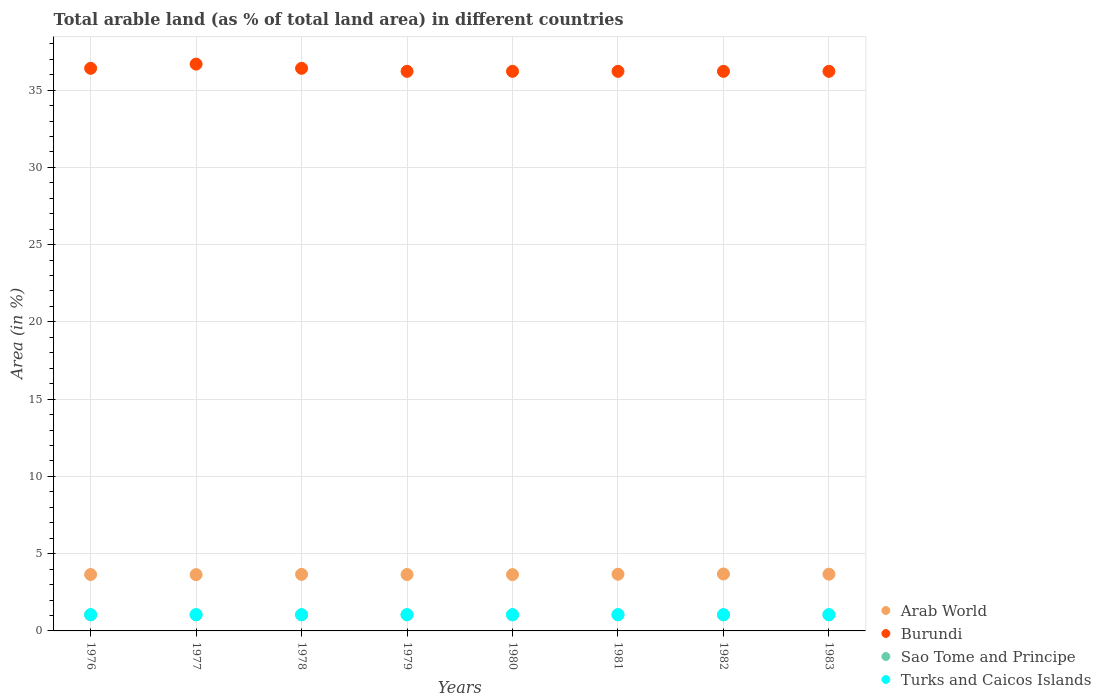What is the percentage of arable land in Burundi in 1980?
Ensure brevity in your answer.  36.21. Across all years, what is the maximum percentage of arable land in Burundi?
Your response must be concise. 36.68. Across all years, what is the minimum percentage of arable land in Arab World?
Offer a very short reply. 3.64. In which year was the percentage of arable land in Burundi maximum?
Your answer should be compact. 1977. In which year was the percentage of arable land in Arab World minimum?
Offer a very short reply. 1977. What is the total percentage of arable land in Turks and Caicos Islands in the graph?
Provide a succinct answer. 8.42. What is the difference between the percentage of arable land in Burundi in 1978 and that in 1979?
Keep it short and to the point. 0.19. What is the difference between the percentage of arable land in Arab World in 1979 and the percentage of arable land in Turks and Caicos Islands in 1983?
Offer a terse response. 2.6. What is the average percentage of arable land in Sao Tome and Principe per year?
Your response must be concise. 1.04. In the year 1980, what is the difference between the percentage of arable land in Turks and Caicos Islands and percentage of arable land in Arab World?
Provide a short and direct response. -2.59. What is the ratio of the percentage of arable land in Burundi in 1976 to that in 1983?
Offer a very short reply. 1.01. Is the difference between the percentage of arable land in Turks and Caicos Islands in 1981 and 1983 greater than the difference between the percentage of arable land in Arab World in 1981 and 1983?
Make the answer very short. Yes. In how many years, is the percentage of arable land in Arab World greater than the average percentage of arable land in Arab World taken over all years?
Provide a short and direct response. 4. Is the sum of the percentage of arable land in Burundi in 1980 and 1982 greater than the maximum percentage of arable land in Arab World across all years?
Offer a terse response. Yes. Is it the case that in every year, the sum of the percentage of arable land in Sao Tome and Principe and percentage of arable land in Burundi  is greater than the sum of percentage of arable land in Turks and Caicos Islands and percentage of arable land in Arab World?
Offer a terse response. Yes. Is it the case that in every year, the sum of the percentage of arable land in Turks and Caicos Islands and percentage of arable land in Burundi  is greater than the percentage of arable land in Arab World?
Ensure brevity in your answer.  Yes. Does the percentage of arable land in Turks and Caicos Islands monotonically increase over the years?
Your answer should be compact. No. Is the percentage of arable land in Burundi strictly less than the percentage of arable land in Arab World over the years?
Your answer should be compact. No. How many years are there in the graph?
Offer a very short reply. 8. What is the difference between two consecutive major ticks on the Y-axis?
Your response must be concise. 5. Does the graph contain any zero values?
Keep it short and to the point. No. Does the graph contain grids?
Offer a terse response. Yes. Where does the legend appear in the graph?
Provide a succinct answer. Bottom right. How are the legend labels stacked?
Make the answer very short. Vertical. What is the title of the graph?
Offer a terse response. Total arable land (as % of total land area) in different countries. What is the label or title of the X-axis?
Keep it short and to the point. Years. What is the label or title of the Y-axis?
Your response must be concise. Area (in %). What is the Area (in %) in Arab World in 1976?
Provide a short and direct response. 3.65. What is the Area (in %) of Burundi in 1976?
Provide a succinct answer. 36.41. What is the Area (in %) in Sao Tome and Principe in 1976?
Your response must be concise. 1.04. What is the Area (in %) in Turks and Caicos Islands in 1976?
Make the answer very short. 1.05. What is the Area (in %) of Arab World in 1977?
Provide a succinct answer. 3.64. What is the Area (in %) in Burundi in 1977?
Make the answer very short. 36.68. What is the Area (in %) of Sao Tome and Principe in 1977?
Provide a succinct answer. 1.04. What is the Area (in %) of Turks and Caicos Islands in 1977?
Make the answer very short. 1.05. What is the Area (in %) in Arab World in 1978?
Ensure brevity in your answer.  3.66. What is the Area (in %) of Burundi in 1978?
Offer a very short reply. 36.41. What is the Area (in %) of Sao Tome and Principe in 1978?
Offer a terse response. 1.04. What is the Area (in %) in Turks and Caicos Islands in 1978?
Your response must be concise. 1.05. What is the Area (in %) in Arab World in 1979?
Offer a terse response. 3.65. What is the Area (in %) in Burundi in 1979?
Provide a succinct answer. 36.21. What is the Area (in %) of Sao Tome and Principe in 1979?
Your answer should be very brief. 1.04. What is the Area (in %) of Turks and Caicos Islands in 1979?
Keep it short and to the point. 1.05. What is the Area (in %) of Arab World in 1980?
Your answer should be very brief. 3.64. What is the Area (in %) in Burundi in 1980?
Your response must be concise. 36.21. What is the Area (in %) of Sao Tome and Principe in 1980?
Provide a succinct answer. 1.04. What is the Area (in %) of Turks and Caicos Islands in 1980?
Your answer should be compact. 1.05. What is the Area (in %) in Arab World in 1981?
Your answer should be compact. 3.67. What is the Area (in %) in Burundi in 1981?
Your answer should be compact. 36.21. What is the Area (in %) in Sao Tome and Principe in 1981?
Ensure brevity in your answer.  1.04. What is the Area (in %) in Turks and Caicos Islands in 1981?
Offer a terse response. 1.05. What is the Area (in %) of Arab World in 1982?
Keep it short and to the point. 3.68. What is the Area (in %) of Burundi in 1982?
Offer a very short reply. 36.21. What is the Area (in %) of Sao Tome and Principe in 1982?
Offer a terse response. 1.04. What is the Area (in %) of Turks and Caicos Islands in 1982?
Provide a succinct answer. 1.05. What is the Area (in %) of Arab World in 1983?
Provide a short and direct response. 3.67. What is the Area (in %) in Burundi in 1983?
Provide a succinct answer. 36.21. What is the Area (in %) in Sao Tome and Principe in 1983?
Ensure brevity in your answer.  1.04. What is the Area (in %) of Turks and Caicos Islands in 1983?
Offer a terse response. 1.05. Across all years, what is the maximum Area (in %) in Arab World?
Offer a terse response. 3.68. Across all years, what is the maximum Area (in %) of Burundi?
Keep it short and to the point. 36.68. Across all years, what is the maximum Area (in %) of Sao Tome and Principe?
Provide a succinct answer. 1.04. Across all years, what is the maximum Area (in %) of Turks and Caicos Islands?
Offer a very short reply. 1.05. Across all years, what is the minimum Area (in %) of Arab World?
Provide a succinct answer. 3.64. Across all years, what is the minimum Area (in %) in Burundi?
Provide a succinct answer. 36.21. Across all years, what is the minimum Area (in %) of Sao Tome and Principe?
Provide a succinct answer. 1.04. Across all years, what is the minimum Area (in %) in Turks and Caicos Islands?
Your answer should be compact. 1.05. What is the total Area (in %) in Arab World in the graph?
Make the answer very short. 29.27. What is the total Area (in %) in Burundi in the graph?
Provide a succinct answer. 290.58. What is the total Area (in %) of Sao Tome and Principe in the graph?
Your answer should be very brief. 8.33. What is the total Area (in %) of Turks and Caicos Islands in the graph?
Offer a terse response. 8.42. What is the difference between the Area (in %) of Arab World in 1976 and that in 1977?
Offer a terse response. 0.01. What is the difference between the Area (in %) in Burundi in 1976 and that in 1977?
Keep it short and to the point. -0.27. What is the difference between the Area (in %) in Arab World in 1976 and that in 1978?
Ensure brevity in your answer.  -0.01. What is the difference between the Area (in %) of Burundi in 1976 and that in 1978?
Provide a short and direct response. 0. What is the difference between the Area (in %) of Sao Tome and Principe in 1976 and that in 1978?
Offer a very short reply. 0. What is the difference between the Area (in %) of Turks and Caicos Islands in 1976 and that in 1978?
Your answer should be very brief. 0. What is the difference between the Area (in %) in Arab World in 1976 and that in 1979?
Your answer should be very brief. -0. What is the difference between the Area (in %) of Burundi in 1976 and that in 1979?
Ensure brevity in your answer.  0.19. What is the difference between the Area (in %) in Sao Tome and Principe in 1976 and that in 1979?
Your answer should be compact. 0. What is the difference between the Area (in %) in Arab World in 1976 and that in 1980?
Offer a terse response. 0.01. What is the difference between the Area (in %) of Burundi in 1976 and that in 1980?
Keep it short and to the point. 0.19. What is the difference between the Area (in %) of Turks and Caicos Islands in 1976 and that in 1980?
Offer a very short reply. 0. What is the difference between the Area (in %) in Arab World in 1976 and that in 1981?
Ensure brevity in your answer.  -0.02. What is the difference between the Area (in %) of Burundi in 1976 and that in 1981?
Provide a short and direct response. 0.19. What is the difference between the Area (in %) of Sao Tome and Principe in 1976 and that in 1981?
Provide a short and direct response. 0. What is the difference between the Area (in %) in Turks and Caicos Islands in 1976 and that in 1981?
Offer a terse response. 0. What is the difference between the Area (in %) of Arab World in 1976 and that in 1982?
Offer a very short reply. -0.03. What is the difference between the Area (in %) of Burundi in 1976 and that in 1982?
Keep it short and to the point. 0.19. What is the difference between the Area (in %) in Turks and Caicos Islands in 1976 and that in 1982?
Ensure brevity in your answer.  0. What is the difference between the Area (in %) in Arab World in 1976 and that in 1983?
Provide a short and direct response. -0.02. What is the difference between the Area (in %) in Burundi in 1976 and that in 1983?
Offer a terse response. 0.19. What is the difference between the Area (in %) of Turks and Caicos Islands in 1976 and that in 1983?
Keep it short and to the point. 0. What is the difference between the Area (in %) in Arab World in 1977 and that in 1978?
Make the answer very short. -0.02. What is the difference between the Area (in %) of Burundi in 1977 and that in 1978?
Keep it short and to the point. 0.27. What is the difference between the Area (in %) of Arab World in 1977 and that in 1979?
Your answer should be very brief. -0.01. What is the difference between the Area (in %) in Burundi in 1977 and that in 1979?
Your answer should be compact. 0.47. What is the difference between the Area (in %) of Sao Tome and Principe in 1977 and that in 1979?
Provide a short and direct response. 0. What is the difference between the Area (in %) of Turks and Caicos Islands in 1977 and that in 1979?
Your response must be concise. 0. What is the difference between the Area (in %) in Arab World in 1977 and that in 1980?
Keep it short and to the point. -0. What is the difference between the Area (in %) in Burundi in 1977 and that in 1980?
Offer a terse response. 0.47. What is the difference between the Area (in %) in Sao Tome and Principe in 1977 and that in 1980?
Ensure brevity in your answer.  0. What is the difference between the Area (in %) in Arab World in 1977 and that in 1981?
Provide a succinct answer. -0.03. What is the difference between the Area (in %) of Burundi in 1977 and that in 1981?
Your answer should be very brief. 0.47. What is the difference between the Area (in %) of Turks and Caicos Islands in 1977 and that in 1981?
Ensure brevity in your answer.  0. What is the difference between the Area (in %) of Arab World in 1977 and that in 1982?
Provide a succinct answer. -0.04. What is the difference between the Area (in %) of Burundi in 1977 and that in 1982?
Provide a succinct answer. 0.47. What is the difference between the Area (in %) of Sao Tome and Principe in 1977 and that in 1982?
Your answer should be very brief. 0. What is the difference between the Area (in %) of Turks and Caicos Islands in 1977 and that in 1982?
Offer a terse response. 0. What is the difference between the Area (in %) of Arab World in 1977 and that in 1983?
Offer a terse response. -0.03. What is the difference between the Area (in %) in Burundi in 1977 and that in 1983?
Your answer should be compact. 0.47. What is the difference between the Area (in %) of Sao Tome and Principe in 1977 and that in 1983?
Your answer should be very brief. 0. What is the difference between the Area (in %) in Arab World in 1978 and that in 1979?
Offer a very short reply. 0.01. What is the difference between the Area (in %) in Burundi in 1978 and that in 1979?
Ensure brevity in your answer.  0.19. What is the difference between the Area (in %) of Arab World in 1978 and that in 1980?
Provide a succinct answer. 0.01. What is the difference between the Area (in %) of Burundi in 1978 and that in 1980?
Your response must be concise. 0.19. What is the difference between the Area (in %) in Arab World in 1978 and that in 1981?
Offer a terse response. -0.01. What is the difference between the Area (in %) of Burundi in 1978 and that in 1981?
Keep it short and to the point. 0.19. What is the difference between the Area (in %) in Turks and Caicos Islands in 1978 and that in 1981?
Provide a short and direct response. 0. What is the difference between the Area (in %) in Arab World in 1978 and that in 1982?
Ensure brevity in your answer.  -0.03. What is the difference between the Area (in %) in Burundi in 1978 and that in 1982?
Keep it short and to the point. 0.19. What is the difference between the Area (in %) of Turks and Caicos Islands in 1978 and that in 1982?
Provide a succinct answer. 0. What is the difference between the Area (in %) in Arab World in 1978 and that in 1983?
Provide a succinct answer. -0.01. What is the difference between the Area (in %) in Burundi in 1978 and that in 1983?
Offer a terse response. 0.19. What is the difference between the Area (in %) of Turks and Caicos Islands in 1978 and that in 1983?
Ensure brevity in your answer.  0. What is the difference between the Area (in %) of Arab World in 1979 and that in 1980?
Give a very brief answer. 0.01. What is the difference between the Area (in %) of Burundi in 1979 and that in 1980?
Your response must be concise. 0. What is the difference between the Area (in %) of Arab World in 1979 and that in 1981?
Offer a very short reply. -0.02. What is the difference between the Area (in %) in Turks and Caicos Islands in 1979 and that in 1981?
Make the answer very short. 0. What is the difference between the Area (in %) of Arab World in 1979 and that in 1982?
Offer a very short reply. -0.03. What is the difference between the Area (in %) in Burundi in 1979 and that in 1982?
Keep it short and to the point. 0. What is the difference between the Area (in %) in Sao Tome and Principe in 1979 and that in 1982?
Give a very brief answer. 0. What is the difference between the Area (in %) of Turks and Caicos Islands in 1979 and that in 1982?
Your response must be concise. 0. What is the difference between the Area (in %) in Arab World in 1979 and that in 1983?
Your response must be concise. -0.02. What is the difference between the Area (in %) in Sao Tome and Principe in 1979 and that in 1983?
Provide a succinct answer. 0. What is the difference between the Area (in %) of Arab World in 1980 and that in 1981?
Keep it short and to the point. -0.02. What is the difference between the Area (in %) of Burundi in 1980 and that in 1981?
Offer a terse response. 0. What is the difference between the Area (in %) of Turks and Caicos Islands in 1980 and that in 1981?
Make the answer very short. 0. What is the difference between the Area (in %) of Arab World in 1980 and that in 1982?
Provide a succinct answer. -0.04. What is the difference between the Area (in %) in Burundi in 1980 and that in 1982?
Ensure brevity in your answer.  0. What is the difference between the Area (in %) in Arab World in 1980 and that in 1983?
Provide a succinct answer. -0.03. What is the difference between the Area (in %) of Burundi in 1980 and that in 1983?
Provide a short and direct response. 0. What is the difference between the Area (in %) in Arab World in 1981 and that in 1982?
Offer a very short reply. -0.02. What is the difference between the Area (in %) in Burundi in 1981 and that in 1982?
Give a very brief answer. 0. What is the difference between the Area (in %) in Sao Tome and Principe in 1981 and that in 1982?
Give a very brief answer. 0. What is the difference between the Area (in %) of Turks and Caicos Islands in 1981 and that in 1982?
Your response must be concise. 0. What is the difference between the Area (in %) of Arab World in 1981 and that in 1983?
Your answer should be compact. -0. What is the difference between the Area (in %) in Arab World in 1982 and that in 1983?
Offer a very short reply. 0.01. What is the difference between the Area (in %) in Burundi in 1982 and that in 1983?
Provide a short and direct response. 0. What is the difference between the Area (in %) in Arab World in 1976 and the Area (in %) in Burundi in 1977?
Your response must be concise. -33.03. What is the difference between the Area (in %) of Arab World in 1976 and the Area (in %) of Sao Tome and Principe in 1977?
Make the answer very short. 2.61. What is the difference between the Area (in %) of Arab World in 1976 and the Area (in %) of Turks and Caicos Islands in 1977?
Provide a short and direct response. 2.6. What is the difference between the Area (in %) of Burundi in 1976 and the Area (in %) of Sao Tome and Principe in 1977?
Provide a short and direct response. 35.37. What is the difference between the Area (in %) of Burundi in 1976 and the Area (in %) of Turks and Caicos Islands in 1977?
Ensure brevity in your answer.  35.36. What is the difference between the Area (in %) in Sao Tome and Principe in 1976 and the Area (in %) in Turks and Caicos Islands in 1977?
Make the answer very short. -0.01. What is the difference between the Area (in %) in Arab World in 1976 and the Area (in %) in Burundi in 1978?
Your answer should be very brief. -32.76. What is the difference between the Area (in %) of Arab World in 1976 and the Area (in %) of Sao Tome and Principe in 1978?
Your response must be concise. 2.61. What is the difference between the Area (in %) in Arab World in 1976 and the Area (in %) in Turks and Caicos Islands in 1978?
Offer a terse response. 2.6. What is the difference between the Area (in %) of Burundi in 1976 and the Area (in %) of Sao Tome and Principe in 1978?
Offer a very short reply. 35.37. What is the difference between the Area (in %) of Burundi in 1976 and the Area (in %) of Turks and Caicos Islands in 1978?
Keep it short and to the point. 35.36. What is the difference between the Area (in %) of Sao Tome and Principe in 1976 and the Area (in %) of Turks and Caicos Islands in 1978?
Make the answer very short. -0.01. What is the difference between the Area (in %) in Arab World in 1976 and the Area (in %) in Burundi in 1979?
Ensure brevity in your answer.  -32.56. What is the difference between the Area (in %) of Arab World in 1976 and the Area (in %) of Sao Tome and Principe in 1979?
Offer a terse response. 2.61. What is the difference between the Area (in %) in Arab World in 1976 and the Area (in %) in Turks and Caicos Islands in 1979?
Make the answer very short. 2.6. What is the difference between the Area (in %) of Burundi in 1976 and the Area (in %) of Sao Tome and Principe in 1979?
Offer a terse response. 35.37. What is the difference between the Area (in %) of Burundi in 1976 and the Area (in %) of Turks and Caicos Islands in 1979?
Your answer should be compact. 35.36. What is the difference between the Area (in %) of Sao Tome and Principe in 1976 and the Area (in %) of Turks and Caicos Islands in 1979?
Keep it short and to the point. -0.01. What is the difference between the Area (in %) of Arab World in 1976 and the Area (in %) of Burundi in 1980?
Keep it short and to the point. -32.56. What is the difference between the Area (in %) of Arab World in 1976 and the Area (in %) of Sao Tome and Principe in 1980?
Provide a succinct answer. 2.61. What is the difference between the Area (in %) of Arab World in 1976 and the Area (in %) of Turks and Caicos Islands in 1980?
Your answer should be compact. 2.6. What is the difference between the Area (in %) of Burundi in 1976 and the Area (in %) of Sao Tome and Principe in 1980?
Give a very brief answer. 35.37. What is the difference between the Area (in %) in Burundi in 1976 and the Area (in %) in Turks and Caicos Islands in 1980?
Offer a terse response. 35.36. What is the difference between the Area (in %) of Sao Tome and Principe in 1976 and the Area (in %) of Turks and Caicos Islands in 1980?
Your answer should be very brief. -0.01. What is the difference between the Area (in %) of Arab World in 1976 and the Area (in %) of Burundi in 1981?
Give a very brief answer. -32.56. What is the difference between the Area (in %) of Arab World in 1976 and the Area (in %) of Sao Tome and Principe in 1981?
Offer a terse response. 2.61. What is the difference between the Area (in %) of Arab World in 1976 and the Area (in %) of Turks and Caicos Islands in 1981?
Provide a succinct answer. 2.6. What is the difference between the Area (in %) in Burundi in 1976 and the Area (in %) in Sao Tome and Principe in 1981?
Your response must be concise. 35.37. What is the difference between the Area (in %) in Burundi in 1976 and the Area (in %) in Turks and Caicos Islands in 1981?
Your answer should be compact. 35.36. What is the difference between the Area (in %) of Sao Tome and Principe in 1976 and the Area (in %) of Turks and Caicos Islands in 1981?
Your answer should be compact. -0.01. What is the difference between the Area (in %) of Arab World in 1976 and the Area (in %) of Burundi in 1982?
Keep it short and to the point. -32.56. What is the difference between the Area (in %) of Arab World in 1976 and the Area (in %) of Sao Tome and Principe in 1982?
Offer a terse response. 2.61. What is the difference between the Area (in %) of Arab World in 1976 and the Area (in %) of Turks and Caicos Islands in 1982?
Your answer should be compact. 2.6. What is the difference between the Area (in %) of Burundi in 1976 and the Area (in %) of Sao Tome and Principe in 1982?
Your answer should be very brief. 35.37. What is the difference between the Area (in %) of Burundi in 1976 and the Area (in %) of Turks and Caicos Islands in 1982?
Provide a short and direct response. 35.36. What is the difference between the Area (in %) in Sao Tome and Principe in 1976 and the Area (in %) in Turks and Caicos Islands in 1982?
Ensure brevity in your answer.  -0.01. What is the difference between the Area (in %) in Arab World in 1976 and the Area (in %) in Burundi in 1983?
Ensure brevity in your answer.  -32.56. What is the difference between the Area (in %) of Arab World in 1976 and the Area (in %) of Sao Tome and Principe in 1983?
Your response must be concise. 2.61. What is the difference between the Area (in %) of Arab World in 1976 and the Area (in %) of Turks and Caicos Islands in 1983?
Ensure brevity in your answer.  2.6. What is the difference between the Area (in %) in Burundi in 1976 and the Area (in %) in Sao Tome and Principe in 1983?
Give a very brief answer. 35.37. What is the difference between the Area (in %) of Burundi in 1976 and the Area (in %) of Turks and Caicos Islands in 1983?
Offer a terse response. 35.36. What is the difference between the Area (in %) of Sao Tome and Principe in 1976 and the Area (in %) of Turks and Caicos Islands in 1983?
Your answer should be very brief. -0.01. What is the difference between the Area (in %) in Arab World in 1977 and the Area (in %) in Burundi in 1978?
Keep it short and to the point. -32.77. What is the difference between the Area (in %) in Arab World in 1977 and the Area (in %) in Sao Tome and Principe in 1978?
Provide a succinct answer. 2.6. What is the difference between the Area (in %) in Arab World in 1977 and the Area (in %) in Turks and Caicos Islands in 1978?
Your answer should be very brief. 2.59. What is the difference between the Area (in %) in Burundi in 1977 and the Area (in %) in Sao Tome and Principe in 1978?
Provide a succinct answer. 35.64. What is the difference between the Area (in %) in Burundi in 1977 and the Area (in %) in Turks and Caicos Islands in 1978?
Offer a terse response. 35.63. What is the difference between the Area (in %) in Sao Tome and Principe in 1977 and the Area (in %) in Turks and Caicos Islands in 1978?
Provide a short and direct response. -0.01. What is the difference between the Area (in %) of Arab World in 1977 and the Area (in %) of Burundi in 1979?
Provide a succinct answer. -32.57. What is the difference between the Area (in %) of Arab World in 1977 and the Area (in %) of Sao Tome and Principe in 1979?
Provide a short and direct response. 2.6. What is the difference between the Area (in %) of Arab World in 1977 and the Area (in %) of Turks and Caicos Islands in 1979?
Provide a succinct answer. 2.59. What is the difference between the Area (in %) in Burundi in 1977 and the Area (in %) in Sao Tome and Principe in 1979?
Your answer should be compact. 35.64. What is the difference between the Area (in %) in Burundi in 1977 and the Area (in %) in Turks and Caicos Islands in 1979?
Provide a succinct answer. 35.63. What is the difference between the Area (in %) of Sao Tome and Principe in 1977 and the Area (in %) of Turks and Caicos Islands in 1979?
Your response must be concise. -0.01. What is the difference between the Area (in %) of Arab World in 1977 and the Area (in %) of Burundi in 1980?
Offer a terse response. -32.57. What is the difference between the Area (in %) of Arab World in 1977 and the Area (in %) of Sao Tome and Principe in 1980?
Provide a succinct answer. 2.6. What is the difference between the Area (in %) of Arab World in 1977 and the Area (in %) of Turks and Caicos Islands in 1980?
Provide a succinct answer. 2.59. What is the difference between the Area (in %) of Burundi in 1977 and the Area (in %) of Sao Tome and Principe in 1980?
Your answer should be compact. 35.64. What is the difference between the Area (in %) of Burundi in 1977 and the Area (in %) of Turks and Caicos Islands in 1980?
Make the answer very short. 35.63. What is the difference between the Area (in %) in Sao Tome and Principe in 1977 and the Area (in %) in Turks and Caicos Islands in 1980?
Provide a succinct answer. -0.01. What is the difference between the Area (in %) in Arab World in 1977 and the Area (in %) in Burundi in 1981?
Ensure brevity in your answer.  -32.57. What is the difference between the Area (in %) of Arab World in 1977 and the Area (in %) of Sao Tome and Principe in 1981?
Give a very brief answer. 2.6. What is the difference between the Area (in %) in Arab World in 1977 and the Area (in %) in Turks and Caicos Islands in 1981?
Your answer should be very brief. 2.59. What is the difference between the Area (in %) in Burundi in 1977 and the Area (in %) in Sao Tome and Principe in 1981?
Provide a short and direct response. 35.64. What is the difference between the Area (in %) in Burundi in 1977 and the Area (in %) in Turks and Caicos Islands in 1981?
Provide a short and direct response. 35.63. What is the difference between the Area (in %) of Sao Tome and Principe in 1977 and the Area (in %) of Turks and Caicos Islands in 1981?
Your answer should be very brief. -0.01. What is the difference between the Area (in %) of Arab World in 1977 and the Area (in %) of Burundi in 1982?
Make the answer very short. -32.57. What is the difference between the Area (in %) of Arab World in 1977 and the Area (in %) of Sao Tome and Principe in 1982?
Your answer should be compact. 2.6. What is the difference between the Area (in %) in Arab World in 1977 and the Area (in %) in Turks and Caicos Islands in 1982?
Your answer should be compact. 2.59. What is the difference between the Area (in %) in Burundi in 1977 and the Area (in %) in Sao Tome and Principe in 1982?
Your answer should be compact. 35.64. What is the difference between the Area (in %) in Burundi in 1977 and the Area (in %) in Turks and Caicos Islands in 1982?
Ensure brevity in your answer.  35.63. What is the difference between the Area (in %) of Sao Tome and Principe in 1977 and the Area (in %) of Turks and Caicos Islands in 1982?
Your response must be concise. -0.01. What is the difference between the Area (in %) of Arab World in 1977 and the Area (in %) of Burundi in 1983?
Offer a very short reply. -32.57. What is the difference between the Area (in %) of Arab World in 1977 and the Area (in %) of Sao Tome and Principe in 1983?
Ensure brevity in your answer.  2.6. What is the difference between the Area (in %) in Arab World in 1977 and the Area (in %) in Turks and Caicos Islands in 1983?
Your response must be concise. 2.59. What is the difference between the Area (in %) of Burundi in 1977 and the Area (in %) of Sao Tome and Principe in 1983?
Your response must be concise. 35.64. What is the difference between the Area (in %) in Burundi in 1977 and the Area (in %) in Turks and Caicos Islands in 1983?
Ensure brevity in your answer.  35.63. What is the difference between the Area (in %) of Sao Tome and Principe in 1977 and the Area (in %) of Turks and Caicos Islands in 1983?
Offer a terse response. -0.01. What is the difference between the Area (in %) of Arab World in 1978 and the Area (in %) of Burundi in 1979?
Keep it short and to the point. -32.56. What is the difference between the Area (in %) of Arab World in 1978 and the Area (in %) of Sao Tome and Principe in 1979?
Offer a very short reply. 2.62. What is the difference between the Area (in %) in Arab World in 1978 and the Area (in %) in Turks and Caicos Islands in 1979?
Provide a short and direct response. 2.61. What is the difference between the Area (in %) in Burundi in 1978 and the Area (in %) in Sao Tome and Principe in 1979?
Your answer should be very brief. 35.37. What is the difference between the Area (in %) in Burundi in 1978 and the Area (in %) in Turks and Caicos Islands in 1979?
Keep it short and to the point. 35.36. What is the difference between the Area (in %) in Sao Tome and Principe in 1978 and the Area (in %) in Turks and Caicos Islands in 1979?
Your response must be concise. -0.01. What is the difference between the Area (in %) in Arab World in 1978 and the Area (in %) in Burundi in 1980?
Offer a terse response. -32.56. What is the difference between the Area (in %) in Arab World in 1978 and the Area (in %) in Sao Tome and Principe in 1980?
Your response must be concise. 2.62. What is the difference between the Area (in %) of Arab World in 1978 and the Area (in %) of Turks and Caicos Islands in 1980?
Your answer should be compact. 2.61. What is the difference between the Area (in %) in Burundi in 1978 and the Area (in %) in Sao Tome and Principe in 1980?
Provide a succinct answer. 35.37. What is the difference between the Area (in %) in Burundi in 1978 and the Area (in %) in Turks and Caicos Islands in 1980?
Provide a succinct answer. 35.36. What is the difference between the Area (in %) of Sao Tome and Principe in 1978 and the Area (in %) of Turks and Caicos Islands in 1980?
Offer a very short reply. -0.01. What is the difference between the Area (in %) in Arab World in 1978 and the Area (in %) in Burundi in 1981?
Your answer should be compact. -32.56. What is the difference between the Area (in %) in Arab World in 1978 and the Area (in %) in Sao Tome and Principe in 1981?
Give a very brief answer. 2.62. What is the difference between the Area (in %) of Arab World in 1978 and the Area (in %) of Turks and Caicos Islands in 1981?
Offer a terse response. 2.61. What is the difference between the Area (in %) in Burundi in 1978 and the Area (in %) in Sao Tome and Principe in 1981?
Provide a short and direct response. 35.37. What is the difference between the Area (in %) of Burundi in 1978 and the Area (in %) of Turks and Caicos Islands in 1981?
Your answer should be very brief. 35.36. What is the difference between the Area (in %) in Sao Tome and Principe in 1978 and the Area (in %) in Turks and Caicos Islands in 1981?
Your answer should be very brief. -0.01. What is the difference between the Area (in %) of Arab World in 1978 and the Area (in %) of Burundi in 1982?
Your answer should be compact. -32.56. What is the difference between the Area (in %) in Arab World in 1978 and the Area (in %) in Sao Tome and Principe in 1982?
Provide a short and direct response. 2.62. What is the difference between the Area (in %) of Arab World in 1978 and the Area (in %) of Turks and Caicos Islands in 1982?
Offer a terse response. 2.61. What is the difference between the Area (in %) in Burundi in 1978 and the Area (in %) in Sao Tome and Principe in 1982?
Provide a short and direct response. 35.37. What is the difference between the Area (in %) in Burundi in 1978 and the Area (in %) in Turks and Caicos Islands in 1982?
Provide a succinct answer. 35.36. What is the difference between the Area (in %) in Sao Tome and Principe in 1978 and the Area (in %) in Turks and Caicos Islands in 1982?
Make the answer very short. -0.01. What is the difference between the Area (in %) in Arab World in 1978 and the Area (in %) in Burundi in 1983?
Your response must be concise. -32.56. What is the difference between the Area (in %) in Arab World in 1978 and the Area (in %) in Sao Tome and Principe in 1983?
Provide a short and direct response. 2.62. What is the difference between the Area (in %) in Arab World in 1978 and the Area (in %) in Turks and Caicos Islands in 1983?
Provide a short and direct response. 2.61. What is the difference between the Area (in %) in Burundi in 1978 and the Area (in %) in Sao Tome and Principe in 1983?
Make the answer very short. 35.37. What is the difference between the Area (in %) of Burundi in 1978 and the Area (in %) of Turks and Caicos Islands in 1983?
Offer a terse response. 35.36. What is the difference between the Area (in %) of Sao Tome and Principe in 1978 and the Area (in %) of Turks and Caicos Islands in 1983?
Keep it short and to the point. -0.01. What is the difference between the Area (in %) of Arab World in 1979 and the Area (in %) of Burundi in 1980?
Offer a very short reply. -32.56. What is the difference between the Area (in %) in Arab World in 1979 and the Area (in %) in Sao Tome and Principe in 1980?
Your answer should be compact. 2.61. What is the difference between the Area (in %) of Arab World in 1979 and the Area (in %) of Turks and Caicos Islands in 1980?
Offer a very short reply. 2.6. What is the difference between the Area (in %) of Burundi in 1979 and the Area (in %) of Sao Tome and Principe in 1980?
Your answer should be compact. 35.17. What is the difference between the Area (in %) in Burundi in 1979 and the Area (in %) in Turks and Caicos Islands in 1980?
Keep it short and to the point. 35.16. What is the difference between the Area (in %) of Sao Tome and Principe in 1979 and the Area (in %) of Turks and Caicos Islands in 1980?
Provide a short and direct response. -0.01. What is the difference between the Area (in %) in Arab World in 1979 and the Area (in %) in Burundi in 1981?
Provide a succinct answer. -32.56. What is the difference between the Area (in %) of Arab World in 1979 and the Area (in %) of Sao Tome and Principe in 1981?
Your response must be concise. 2.61. What is the difference between the Area (in %) in Arab World in 1979 and the Area (in %) in Turks and Caicos Islands in 1981?
Provide a succinct answer. 2.6. What is the difference between the Area (in %) of Burundi in 1979 and the Area (in %) of Sao Tome and Principe in 1981?
Your response must be concise. 35.17. What is the difference between the Area (in %) in Burundi in 1979 and the Area (in %) in Turks and Caicos Islands in 1981?
Your response must be concise. 35.16. What is the difference between the Area (in %) in Sao Tome and Principe in 1979 and the Area (in %) in Turks and Caicos Islands in 1981?
Provide a short and direct response. -0.01. What is the difference between the Area (in %) of Arab World in 1979 and the Area (in %) of Burundi in 1982?
Offer a terse response. -32.56. What is the difference between the Area (in %) of Arab World in 1979 and the Area (in %) of Sao Tome and Principe in 1982?
Offer a very short reply. 2.61. What is the difference between the Area (in %) in Arab World in 1979 and the Area (in %) in Turks and Caicos Islands in 1982?
Provide a succinct answer. 2.6. What is the difference between the Area (in %) in Burundi in 1979 and the Area (in %) in Sao Tome and Principe in 1982?
Your answer should be compact. 35.17. What is the difference between the Area (in %) of Burundi in 1979 and the Area (in %) of Turks and Caicos Islands in 1982?
Make the answer very short. 35.16. What is the difference between the Area (in %) of Sao Tome and Principe in 1979 and the Area (in %) of Turks and Caicos Islands in 1982?
Give a very brief answer. -0.01. What is the difference between the Area (in %) of Arab World in 1979 and the Area (in %) of Burundi in 1983?
Give a very brief answer. -32.56. What is the difference between the Area (in %) of Arab World in 1979 and the Area (in %) of Sao Tome and Principe in 1983?
Offer a very short reply. 2.61. What is the difference between the Area (in %) of Arab World in 1979 and the Area (in %) of Turks and Caicos Islands in 1983?
Provide a short and direct response. 2.6. What is the difference between the Area (in %) of Burundi in 1979 and the Area (in %) of Sao Tome and Principe in 1983?
Ensure brevity in your answer.  35.17. What is the difference between the Area (in %) in Burundi in 1979 and the Area (in %) in Turks and Caicos Islands in 1983?
Offer a very short reply. 35.16. What is the difference between the Area (in %) in Sao Tome and Principe in 1979 and the Area (in %) in Turks and Caicos Islands in 1983?
Make the answer very short. -0.01. What is the difference between the Area (in %) in Arab World in 1980 and the Area (in %) in Burundi in 1981?
Provide a succinct answer. -32.57. What is the difference between the Area (in %) in Arab World in 1980 and the Area (in %) in Sao Tome and Principe in 1981?
Give a very brief answer. 2.6. What is the difference between the Area (in %) of Arab World in 1980 and the Area (in %) of Turks and Caicos Islands in 1981?
Make the answer very short. 2.59. What is the difference between the Area (in %) of Burundi in 1980 and the Area (in %) of Sao Tome and Principe in 1981?
Ensure brevity in your answer.  35.17. What is the difference between the Area (in %) of Burundi in 1980 and the Area (in %) of Turks and Caicos Islands in 1981?
Your answer should be compact. 35.16. What is the difference between the Area (in %) of Sao Tome and Principe in 1980 and the Area (in %) of Turks and Caicos Islands in 1981?
Make the answer very short. -0.01. What is the difference between the Area (in %) in Arab World in 1980 and the Area (in %) in Burundi in 1982?
Make the answer very short. -32.57. What is the difference between the Area (in %) in Arab World in 1980 and the Area (in %) in Sao Tome and Principe in 1982?
Make the answer very short. 2.6. What is the difference between the Area (in %) in Arab World in 1980 and the Area (in %) in Turks and Caicos Islands in 1982?
Give a very brief answer. 2.59. What is the difference between the Area (in %) of Burundi in 1980 and the Area (in %) of Sao Tome and Principe in 1982?
Ensure brevity in your answer.  35.17. What is the difference between the Area (in %) of Burundi in 1980 and the Area (in %) of Turks and Caicos Islands in 1982?
Offer a very short reply. 35.16. What is the difference between the Area (in %) of Sao Tome and Principe in 1980 and the Area (in %) of Turks and Caicos Islands in 1982?
Offer a terse response. -0.01. What is the difference between the Area (in %) in Arab World in 1980 and the Area (in %) in Burundi in 1983?
Your response must be concise. -32.57. What is the difference between the Area (in %) in Arab World in 1980 and the Area (in %) in Sao Tome and Principe in 1983?
Your answer should be very brief. 2.6. What is the difference between the Area (in %) of Arab World in 1980 and the Area (in %) of Turks and Caicos Islands in 1983?
Make the answer very short. 2.59. What is the difference between the Area (in %) of Burundi in 1980 and the Area (in %) of Sao Tome and Principe in 1983?
Offer a terse response. 35.17. What is the difference between the Area (in %) in Burundi in 1980 and the Area (in %) in Turks and Caicos Islands in 1983?
Provide a short and direct response. 35.16. What is the difference between the Area (in %) in Sao Tome and Principe in 1980 and the Area (in %) in Turks and Caicos Islands in 1983?
Keep it short and to the point. -0.01. What is the difference between the Area (in %) of Arab World in 1981 and the Area (in %) of Burundi in 1982?
Provide a short and direct response. -32.55. What is the difference between the Area (in %) in Arab World in 1981 and the Area (in %) in Sao Tome and Principe in 1982?
Your answer should be very brief. 2.63. What is the difference between the Area (in %) in Arab World in 1981 and the Area (in %) in Turks and Caicos Islands in 1982?
Your answer should be compact. 2.62. What is the difference between the Area (in %) in Burundi in 1981 and the Area (in %) in Sao Tome and Principe in 1982?
Ensure brevity in your answer.  35.17. What is the difference between the Area (in %) in Burundi in 1981 and the Area (in %) in Turks and Caicos Islands in 1982?
Offer a terse response. 35.16. What is the difference between the Area (in %) in Sao Tome and Principe in 1981 and the Area (in %) in Turks and Caicos Islands in 1982?
Provide a short and direct response. -0.01. What is the difference between the Area (in %) of Arab World in 1981 and the Area (in %) of Burundi in 1983?
Offer a terse response. -32.55. What is the difference between the Area (in %) in Arab World in 1981 and the Area (in %) in Sao Tome and Principe in 1983?
Keep it short and to the point. 2.63. What is the difference between the Area (in %) of Arab World in 1981 and the Area (in %) of Turks and Caicos Islands in 1983?
Your response must be concise. 2.62. What is the difference between the Area (in %) in Burundi in 1981 and the Area (in %) in Sao Tome and Principe in 1983?
Give a very brief answer. 35.17. What is the difference between the Area (in %) of Burundi in 1981 and the Area (in %) of Turks and Caicos Islands in 1983?
Keep it short and to the point. 35.16. What is the difference between the Area (in %) of Sao Tome and Principe in 1981 and the Area (in %) of Turks and Caicos Islands in 1983?
Keep it short and to the point. -0.01. What is the difference between the Area (in %) of Arab World in 1982 and the Area (in %) of Burundi in 1983?
Your answer should be compact. -32.53. What is the difference between the Area (in %) of Arab World in 1982 and the Area (in %) of Sao Tome and Principe in 1983?
Your answer should be compact. 2.64. What is the difference between the Area (in %) in Arab World in 1982 and the Area (in %) in Turks and Caicos Islands in 1983?
Make the answer very short. 2.63. What is the difference between the Area (in %) in Burundi in 1982 and the Area (in %) in Sao Tome and Principe in 1983?
Your answer should be very brief. 35.17. What is the difference between the Area (in %) of Burundi in 1982 and the Area (in %) of Turks and Caicos Islands in 1983?
Keep it short and to the point. 35.16. What is the difference between the Area (in %) in Sao Tome and Principe in 1982 and the Area (in %) in Turks and Caicos Islands in 1983?
Ensure brevity in your answer.  -0.01. What is the average Area (in %) of Arab World per year?
Give a very brief answer. 3.66. What is the average Area (in %) of Burundi per year?
Your answer should be very brief. 36.32. What is the average Area (in %) of Sao Tome and Principe per year?
Offer a terse response. 1.04. What is the average Area (in %) of Turks and Caicos Islands per year?
Keep it short and to the point. 1.05. In the year 1976, what is the difference between the Area (in %) in Arab World and Area (in %) in Burundi?
Provide a succinct answer. -32.76. In the year 1976, what is the difference between the Area (in %) in Arab World and Area (in %) in Sao Tome and Principe?
Keep it short and to the point. 2.61. In the year 1976, what is the difference between the Area (in %) of Arab World and Area (in %) of Turks and Caicos Islands?
Offer a very short reply. 2.6. In the year 1976, what is the difference between the Area (in %) in Burundi and Area (in %) in Sao Tome and Principe?
Keep it short and to the point. 35.37. In the year 1976, what is the difference between the Area (in %) of Burundi and Area (in %) of Turks and Caicos Islands?
Your answer should be compact. 35.36. In the year 1976, what is the difference between the Area (in %) of Sao Tome and Principe and Area (in %) of Turks and Caicos Islands?
Your answer should be compact. -0.01. In the year 1977, what is the difference between the Area (in %) in Arab World and Area (in %) in Burundi?
Your answer should be compact. -33.04. In the year 1977, what is the difference between the Area (in %) in Arab World and Area (in %) in Sao Tome and Principe?
Provide a short and direct response. 2.6. In the year 1977, what is the difference between the Area (in %) in Arab World and Area (in %) in Turks and Caicos Islands?
Offer a very short reply. 2.59. In the year 1977, what is the difference between the Area (in %) of Burundi and Area (in %) of Sao Tome and Principe?
Ensure brevity in your answer.  35.64. In the year 1977, what is the difference between the Area (in %) of Burundi and Area (in %) of Turks and Caicos Islands?
Make the answer very short. 35.63. In the year 1977, what is the difference between the Area (in %) of Sao Tome and Principe and Area (in %) of Turks and Caicos Islands?
Your answer should be compact. -0.01. In the year 1978, what is the difference between the Area (in %) of Arab World and Area (in %) of Burundi?
Your answer should be very brief. -32.75. In the year 1978, what is the difference between the Area (in %) of Arab World and Area (in %) of Sao Tome and Principe?
Your answer should be compact. 2.62. In the year 1978, what is the difference between the Area (in %) in Arab World and Area (in %) in Turks and Caicos Islands?
Your answer should be very brief. 2.61. In the year 1978, what is the difference between the Area (in %) of Burundi and Area (in %) of Sao Tome and Principe?
Provide a short and direct response. 35.37. In the year 1978, what is the difference between the Area (in %) of Burundi and Area (in %) of Turks and Caicos Islands?
Your answer should be compact. 35.36. In the year 1978, what is the difference between the Area (in %) of Sao Tome and Principe and Area (in %) of Turks and Caicos Islands?
Make the answer very short. -0.01. In the year 1979, what is the difference between the Area (in %) of Arab World and Area (in %) of Burundi?
Keep it short and to the point. -32.56. In the year 1979, what is the difference between the Area (in %) of Arab World and Area (in %) of Sao Tome and Principe?
Provide a succinct answer. 2.61. In the year 1979, what is the difference between the Area (in %) of Arab World and Area (in %) of Turks and Caicos Islands?
Keep it short and to the point. 2.6. In the year 1979, what is the difference between the Area (in %) in Burundi and Area (in %) in Sao Tome and Principe?
Ensure brevity in your answer.  35.17. In the year 1979, what is the difference between the Area (in %) in Burundi and Area (in %) in Turks and Caicos Islands?
Provide a short and direct response. 35.16. In the year 1979, what is the difference between the Area (in %) in Sao Tome and Principe and Area (in %) in Turks and Caicos Islands?
Provide a succinct answer. -0.01. In the year 1980, what is the difference between the Area (in %) of Arab World and Area (in %) of Burundi?
Your response must be concise. -32.57. In the year 1980, what is the difference between the Area (in %) of Arab World and Area (in %) of Sao Tome and Principe?
Offer a terse response. 2.6. In the year 1980, what is the difference between the Area (in %) of Arab World and Area (in %) of Turks and Caicos Islands?
Ensure brevity in your answer.  2.59. In the year 1980, what is the difference between the Area (in %) of Burundi and Area (in %) of Sao Tome and Principe?
Your response must be concise. 35.17. In the year 1980, what is the difference between the Area (in %) in Burundi and Area (in %) in Turks and Caicos Islands?
Your answer should be compact. 35.16. In the year 1980, what is the difference between the Area (in %) of Sao Tome and Principe and Area (in %) of Turks and Caicos Islands?
Your answer should be very brief. -0.01. In the year 1981, what is the difference between the Area (in %) in Arab World and Area (in %) in Burundi?
Provide a succinct answer. -32.55. In the year 1981, what is the difference between the Area (in %) of Arab World and Area (in %) of Sao Tome and Principe?
Give a very brief answer. 2.63. In the year 1981, what is the difference between the Area (in %) of Arab World and Area (in %) of Turks and Caicos Islands?
Your answer should be very brief. 2.62. In the year 1981, what is the difference between the Area (in %) in Burundi and Area (in %) in Sao Tome and Principe?
Keep it short and to the point. 35.17. In the year 1981, what is the difference between the Area (in %) in Burundi and Area (in %) in Turks and Caicos Islands?
Your answer should be very brief. 35.16. In the year 1981, what is the difference between the Area (in %) in Sao Tome and Principe and Area (in %) in Turks and Caicos Islands?
Your response must be concise. -0.01. In the year 1982, what is the difference between the Area (in %) of Arab World and Area (in %) of Burundi?
Make the answer very short. -32.53. In the year 1982, what is the difference between the Area (in %) in Arab World and Area (in %) in Sao Tome and Principe?
Your answer should be compact. 2.64. In the year 1982, what is the difference between the Area (in %) of Arab World and Area (in %) of Turks and Caicos Islands?
Keep it short and to the point. 2.63. In the year 1982, what is the difference between the Area (in %) of Burundi and Area (in %) of Sao Tome and Principe?
Provide a succinct answer. 35.17. In the year 1982, what is the difference between the Area (in %) of Burundi and Area (in %) of Turks and Caicos Islands?
Keep it short and to the point. 35.16. In the year 1982, what is the difference between the Area (in %) in Sao Tome and Principe and Area (in %) in Turks and Caicos Islands?
Your answer should be very brief. -0.01. In the year 1983, what is the difference between the Area (in %) in Arab World and Area (in %) in Burundi?
Your answer should be very brief. -32.54. In the year 1983, what is the difference between the Area (in %) of Arab World and Area (in %) of Sao Tome and Principe?
Provide a succinct answer. 2.63. In the year 1983, what is the difference between the Area (in %) of Arab World and Area (in %) of Turks and Caicos Islands?
Your answer should be compact. 2.62. In the year 1983, what is the difference between the Area (in %) in Burundi and Area (in %) in Sao Tome and Principe?
Offer a terse response. 35.17. In the year 1983, what is the difference between the Area (in %) in Burundi and Area (in %) in Turks and Caicos Islands?
Your answer should be compact. 35.16. In the year 1983, what is the difference between the Area (in %) in Sao Tome and Principe and Area (in %) in Turks and Caicos Islands?
Offer a very short reply. -0.01. What is the ratio of the Area (in %) in Arab World in 1976 to that in 1977?
Ensure brevity in your answer.  1. What is the ratio of the Area (in %) in Burundi in 1976 to that in 1977?
Give a very brief answer. 0.99. What is the ratio of the Area (in %) in Sao Tome and Principe in 1976 to that in 1977?
Your answer should be compact. 1. What is the ratio of the Area (in %) of Turks and Caicos Islands in 1976 to that in 1977?
Your answer should be compact. 1. What is the ratio of the Area (in %) in Arab World in 1976 to that in 1978?
Keep it short and to the point. 1. What is the ratio of the Area (in %) in Burundi in 1976 to that in 1978?
Offer a very short reply. 1. What is the ratio of the Area (in %) of Sao Tome and Principe in 1976 to that in 1978?
Ensure brevity in your answer.  1. What is the ratio of the Area (in %) of Arab World in 1976 to that in 1979?
Your answer should be compact. 1. What is the ratio of the Area (in %) in Burundi in 1976 to that in 1979?
Make the answer very short. 1.01. What is the ratio of the Area (in %) in Turks and Caicos Islands in 1976 to that in 1979?
Offer a terse response. 1. What is the ratio of the Area (in %) of Arab World in 1976 to that in 1980?
Your response must be concise. 1. What is the ratio of the Area (in %) of Burundi in 1976 to that in 1980?
Give a very brief answer. 1.01. What is the ratio of the Area (in %) of Sao Tome and Principe in 1976 to that in 1980?
Your answer should be very brief. 1. What is the ratio of the Area (in %) of Burundi in 1976 to that in 1981?
Give a very brief answer. 1.01. What is the ratio of the Area (in %) of Sao Tome and Principe in 1976 to that in 1981?
Provide a short and direct response. 1. What is the ratio of the Area (in %) in Burundi in 1976 to that in 1982?
Make the answer very short. 1.01. What is the ratio of the Area (in %) in Turks and Caicos Islands in 1976 to that in 1982?
Give a very brief answer. 1. What is the ratio of the Area (in %) in Burundi in 1976 to that in 1983?
Make the answer very short. 1.01. What is the ratio of the Area (in %) of Burundi in 1977 to that in 1978?
Your answer should be very brief. 1.01. What is the ratio of the Area (in %) in Burundi in 1977 to that in 1979?
Offer a terse response. 1.01. What is the ratio of the Area (in %) in Arab World in 1977 to that in 1980?
Offer a terse response. 1. What is the ratio of the Area (in %) in Burundi in 1977 to that in 1980?
Your answer should be very brief. 1.01. What is the ratio of the Area (in %) in Sao Tome and Principe in 1977 to that in 1980?
Provide a short and direct response. 1. What is the ratio of the Area (in %) in Turks and Caicos Islands in 1977 to that in 1980?
Your response must be concise. 1. What is the ratio of the Area (in %) of Arab World in 1977 to that in 1981?
Offer a terse response. 0.99. What is the ratio of the Area (in %) of Burundi in 1977 to that in 1981?
Your answer should be very brief. 1.01. What is the ratio of the Area (in %) of Sao Tome and Principe in 1977 to that in 1981?
Offer a very short reply. 1. What is the ratio of the Area (in %) in Arab World in 1977 to that in 1982?
Provide a short and direct response. 0.99. What is the ratio of the Area (in %) in Burundi in 1977 to that in 1982?
Your answer should be very brief. 1.01. What is the ratio of the Area (in %) in Burundi in 1977 to that in 1983?
Ensure brevity in your answer.  1.01. What is the ratio of the Area (in %) in Sao Tome and Principe in 1977 to that in 1983?
Keep it short and to the point. 1. What is the ratio of the Area (in %) of Burundi in 1978 to that in 1979?
Your answer should be compact. 1.01. What is the ratio of the Area (in %) of Sao Tome and Principe in 1978 to that in 1979?
Provide a succinct answer. 1. What is the ratio of the Area (in %) in Turks and Caicos Islands in 1978 to that in 1979?
Make the answer very short. 1. What is the ratio of the Area (in %) of Arab World in 1978 to that in 1980?
Offer a terse response. 1. What is the ratio of the Area (in %) in Burundi in 1978 to that in 1980?
Your answer should be compact. 1.01. What is the ratio of the Area (in %) in Turks and Caicos Islands in 1978 to that in 1980?
Make the answer very short. 1. What is the ratio of the Area (in %) of Arab World in 1978 to that in 1981?
Give a very brief answer. 1. What is the ratio of the Area (in %) in Burundi in 1978 to that in 1981?
Provide a short and direct response. 1.01. What is the ratio of the Area (in %) of Turks and Caicos Islands in 1978 to that in 1981?
Your response must be concise. 1. What is the ratio of the Area (in %) of Arab World in 1978 to that in 1982?
Provide a short and direct response. 0.99. What is the ratio of the Area (in %) in Burundi in 1978 to that in 1982?
Provide a short and direct response. 1.01. What is the ratio of the Area (in %) of Arab World in 1978 to that in 1983?
Keep it short and to the point. 1. What is the ratio of the Area (in %) of Burundi in 1978 to that in 1983?
Make the answer very short. 1.01. What is the ratio of the Area (in %) in Turks and Caicos Islands in 1978 to that in 1983?
Your response must be concise. 1. What is the ratio of the Area (in %) of Arab World in 1979 to that in 1982?
Provide a short and direct response. 0.99. What is the ratio of the Area (in %) of Arab World in 1979 to that in 1983?
Provide a succinct answer. 0.99. What is the ratio of the Area (in %) of Sao Tome and Principe in 1979 to that in 1983?
Offer a very short reply. 1. What is the ratio of the Area (in %) of Turks and Caicos Islands in 1979 to that in 1983?
Your answer should be very brief. 1. What is the ratio of the Area (in %) in Sao Tome and Principe in 1980 to that in 1981?
Provide a short and direct response. 1. What is the ratio of the Area (in %) of Arab World in 1980 to that in 1982?
Provide a succinct answer. 0.99. What is the ratio of the Area (in %) in Burundi in 1980 to that in 1982?
Make the answer very short. 1. What is the ratio of the Area (in %) of Turks and Caicos Islands in 1980 to that in 1982?
Make the answer very short. 1. What is the ratio of the Area (in %) of Turks and Caicos Islands in 1980 to that in 1983?
Provide a succinct answer. 1. What is the ratio of the Area (in %) of Burundi in 1981 to that in 1982?
Your response must be concise. 1. What is the ratio of the Area (in %) of Arab World in 1981 to that in 1983?
Your answer should be very brief. 1. What is the ratio of the Area (in %) of Burundi in 1981 to that in 1983?
Your answer should be very brief. 1. What is the ratio of the Area (in %) of Burundi in 1982 to that in 1983?
Your answer should be very brief. 1. What is the difference between the highest and the second highest Area (in %) of Arab World?
Give a very brief answer. 0.01. What is the difference between the highest and the second highest Area (in %) in Burundi?
Keep it short and to the point. 0.27. What is the difference between the highest and the second highest Area (in %) of Sao Tome and Principe?
Your answer should be compact. 0. What is the difference between the highest and the lowest Area (in %) of Arab World?
Offer a very short reply. 0.04. What is the difference between the highest and the lowest Area (in %) in Burundi?
Provide a short and direct response. 0.47. What is the difference between the highest and the lowest Area (in %) in Sao Tome and Principe?
Your answer should be very brief. 0. What is the difference between the highest and the lowest Area (in %) in Turks and Caicos Islands?
Offer a very short reply. 0. 